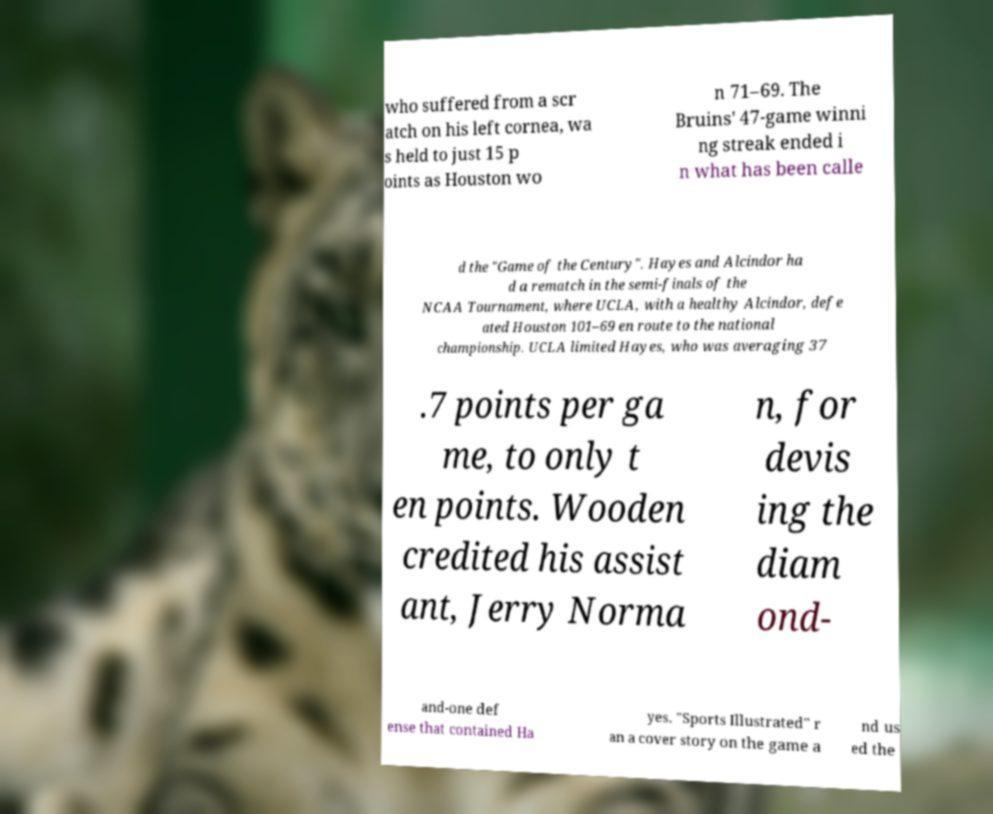Please identify and transcribe the text found in this image. who suffered from a scr atch on his left cornea, wa s held to just 15 p oints as Houston wo n 71–69. The Bruins' 47-game winni ng streak ended i n what has been calle d the "Game of the Century". Hayes and Alcindor ha d a rematch in the semi-finals of the NCAA Tournament, where UCLA, with a healthy Alcindor, defe ated Houston 101–69 en route to the national championship. UCLA limited Hayes, who was averaging 37 .7 points per ga me, to only t en points. Wooden credited his assist ant, Jerry Norma n, for devis ing the diam ond- and-one def ense that contained Ha yes. "Sports Illustrated" r an a cover story on the game a nd us ed the 